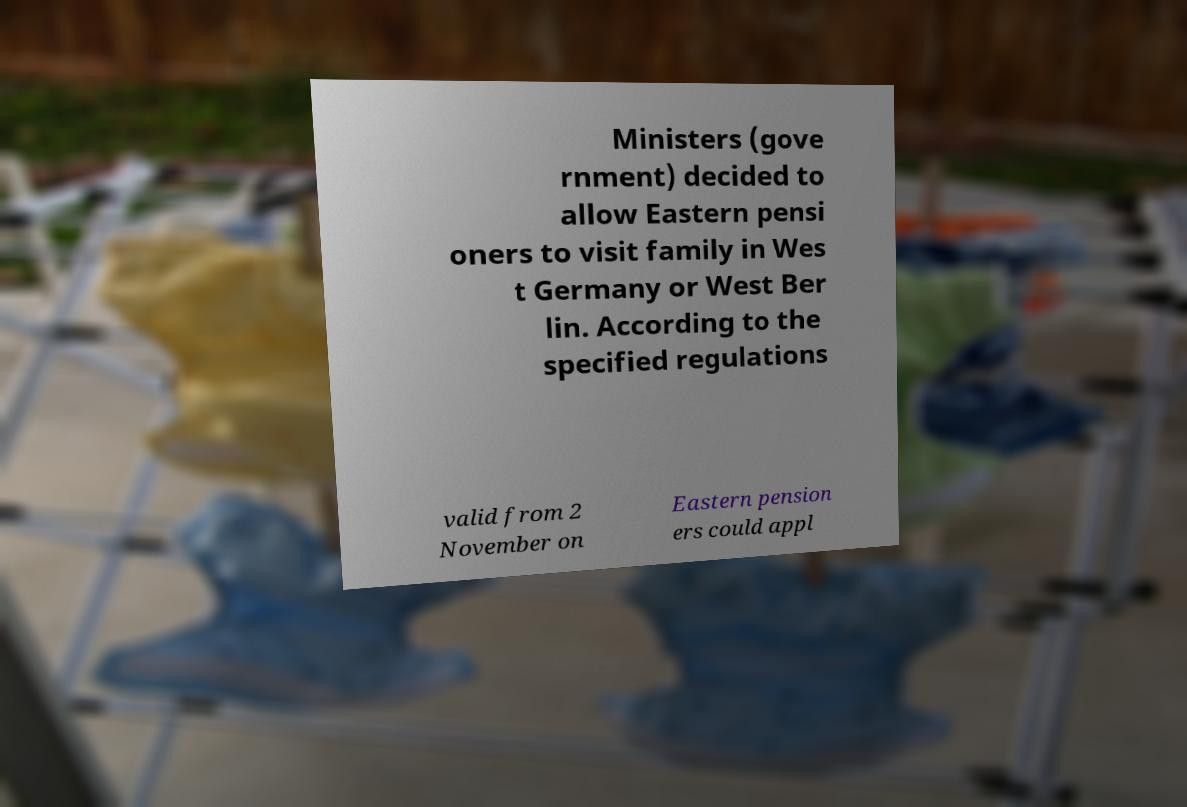Please identify and transcribe the text found in this image. Ministers (gove rnment) decided to allow Eastern pensi oners to visit family in Wes t Germany or West Ber lin. According to the specified regulations valid from 2 November on Eastern pension ers could appl 